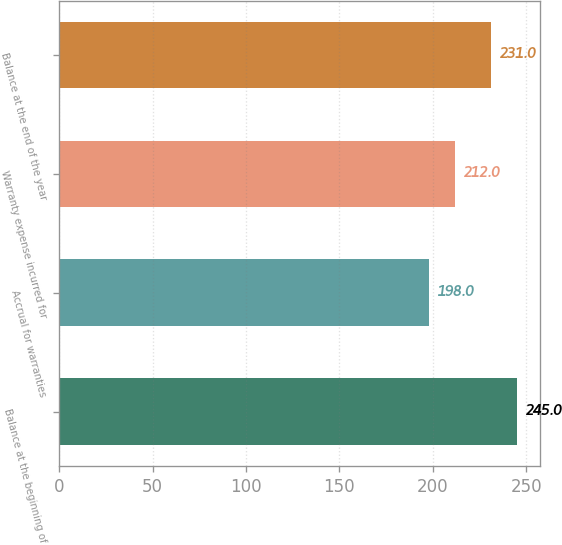<chart> <loc_0><loc_0><loc_500><loc_500><bar_chart><fcel>Balance at the beginning of<fcel>Accrual for warranties<fcel>Warranty expense incurred for<fcel>Balance at the end of the year<nl><fcel>245<fcel>198<fcel>212<fcel>231<nl></chart> 